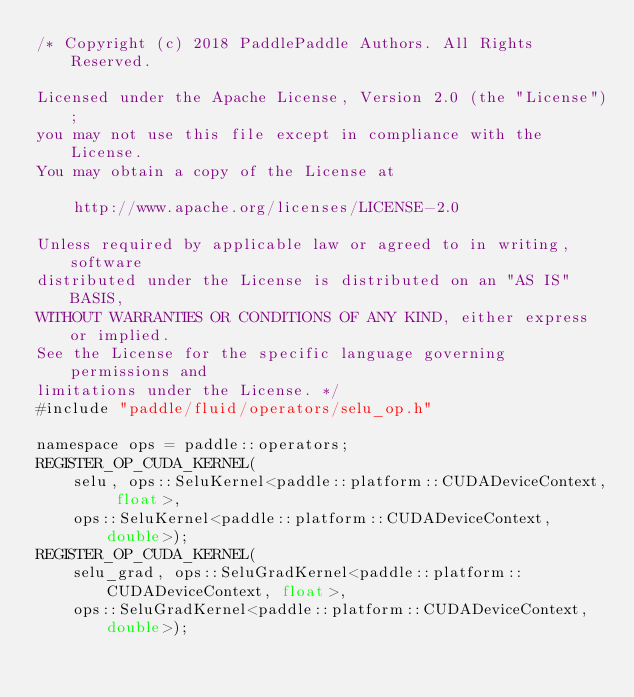<code> <loc_0><loc_0><loc_500><loc_500><_Cuda_>/* Copyright (c) 2018 PaddlePaddle Authors. All Rights Reserved.

Licensed under the Apache License, Version 2.0 (the "License");
you may not use this file except in compliance with the License.
You may obtain a copy of the License at

    http://www.apache.org/licenses/LICENSE-2.0

Unless required by applicable law or agreed to in writing, software
distributed under the License is distributed on an "AS IS" BASIS,
WITHOUT WARRANTIES OR CONDITIONS OF ANY KIND, either express or implied.
See the License for the specific language governing permissions and
limitations under the License. */
#include "paddle/fluid/operators/selu_op.h"

namespace ops = paddle::operators;
REGISTER_OP_CUDA_KERNEL(
    selu, ops::SeluKernel<paddle::platform::CUDADeviceContext, float>,
    ops::SeluKernel<paddle::platform::CUDADeviceContext, double>);
REGISTER_OP_CUDA_KERNEL(
    selu_grad, ops::SeluGradKernel<paddle::platform::CUDADeviceContext, float>,
    ops::SeluGradKernel<paddle::platform::CUDADeviceContext, double>);
</code> 